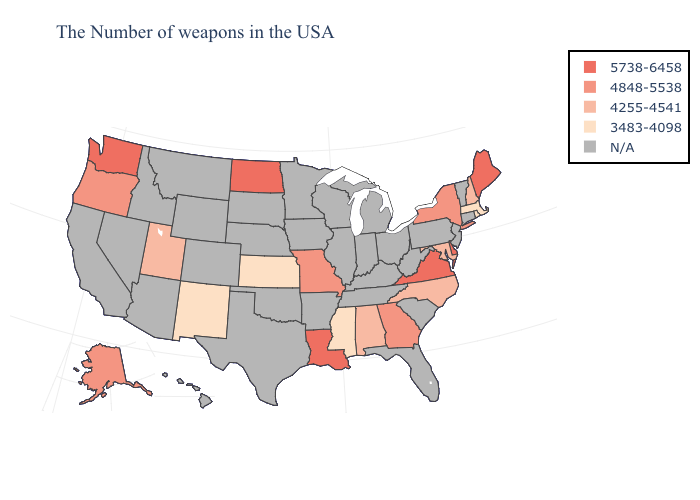What is the lowest value in states that border Maine?
Write a very short answer. 4255-4541. What is the value of Illinois?
Concise answer only. N/A. What is the highest value in the USA?
Short answer required. 5738-6458. Does New Mexico have the lowest value in the USA?
Answer briefly. Yes. What is the highest value in the West ?
Write a very short answer. 5738-6458. Which states hav the highest value in the Northeast?
Write a very short answer. Maine. Name the states that have a value in the range 3483-4098?
Keep it brief. Massachusetts, Rhode Island, Mississippi, Kansas, New Mexico. Does Washington have the lowest value in the USA?
Quick response, please. No. What is the lowest value in states that border North Carolina?
Concise answer only. 4848-5538. Name the states that have a value in the range 4848-5538?
Write a very short answer. New York, Georgia, Missouri, Oregon, Alaska. What is the value of New Hampshire?
Concise answer only. 4255-4541. Name the states that have a value in the range 3483-4098?
Quick response, please. Massachusetts, Rhode Island, Mississippi, Kansas, New Mexico. 